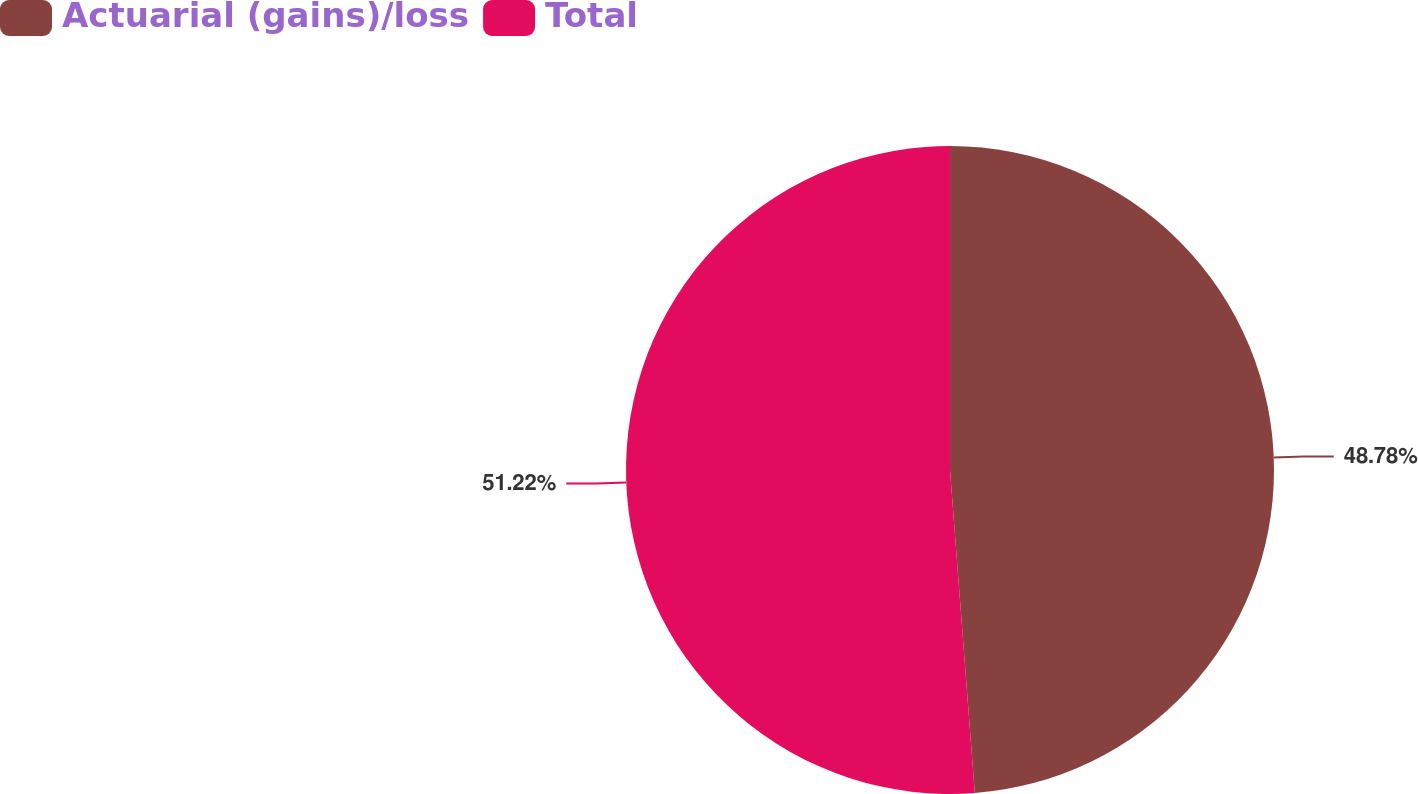Convert chart. <chart><loc_0><loc_0><loc_500><loc_500><pie_chart><fcel>Actuarial (gains)/loss<fcel>Total<nl><fcel>48.78%<fcel>51.22%<nl></chart> 